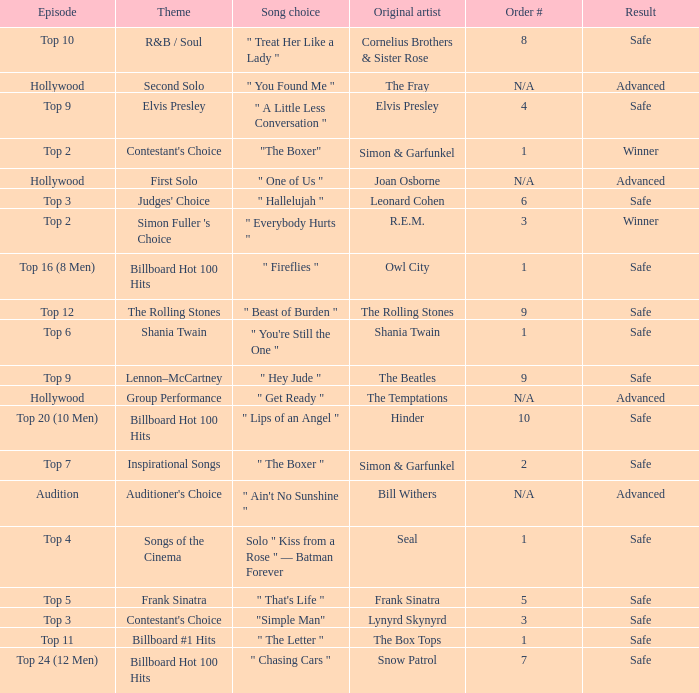In episode Top 16 (8 Men), what are the themes? Billboard Hot 100 Hits. Could you help me parse every detail presented in this table? {'header': ['Episode', 'Theme', 'Song choice', 'Original artist', 'Order #', 'Result'], 'rows': [['Top 10', 'R&B / Soul', '" Treat Her Like a Lady "', 'Cornelius Brothers & Sister Rose', '8', 'Safe'], ['Hollywood', 'Second Solo', '" You Found Me "', 'The Fray', 'N/A', 'Advanced'], ['Top 9', 'Elvis Presley', '" A Little Less Conversation "', 'Elvis Presley', '4', 'Safe'], ['Top 2', "Contestant's Choice", '"The Boxer"', 'Simon & Garfunkel', '1', 'Winner'], ['Hollywood', 'First Solo', '" One of Us "', 'Joan Osborne', 'N/A', 'Advanced'], ['Top 3', "Judges' Choice", '" Hallelujah "', 'Leonard Cohen', '6', 'Safe'], ['Top 2', "Simon Fuller 's Choice", '" Everybody Hurts "', 'R.E.M.', '3', 'Winner'], ['Top 16 (8 Men)', 'Billboard Hot 100 Hits', '" Fireflies "', 'Owl City', '1', 'Safe'], ['Top 12', 'The Rolling Stones', '" Beast of Burden "', 'The Rolling Stones', '9', 'Safe'], ['Top 6', 'Shania Twain', '" You\'re Still the One "', 'Shania Twain', '1', 'Safe'], ['Top 9', 'Lennon–McCartney', '" Hey Jude "', 'The Beatles', '9', 'Safe'], ['Hollywood', 'Group Performance', '" Get Ready "', 'The Temptations', 'N/A', 'Advanced'], ['Top 20 (10 Men)', 'Billboard Hot 100 Hits', '" Lips of an Angel "', 'Hinder', '10', 'Safe'], ['Top 7', 'Inspirational Songs', '" The Boxer "', 'Simon & Garfunkel', '2', 'Safe'], ['Audition', "Auditioner's Choice", '" Ain\'t No Sunshine "', 'Bill Withers', 'N/A', 'Advanced'], ['Top 4', 'Songs of the Cinema', 'Solo " Kiss from a Rose " — Batman Forever', 'Seal', '1', 'Safe'], ['Top 5', 'Frank Sinatra', '" That\'s Life "', 'Frank Sinatra', '5', 'Safe'], ['Top 3', "Contestant's Choice", '"Simple Man"', 'Lynyrd Skynyrd', '3', 'Safe'], ['Top 11', 'Billboard #1 Hits', '" The Letter "', 'The Box Tops', '1', 'Safe'], ['Top 24 (12 Men)', 'Billboard Hot 100 Hits', '" Chasing Cars "', 'Snow Patrol', '7', 'Safe']]} 